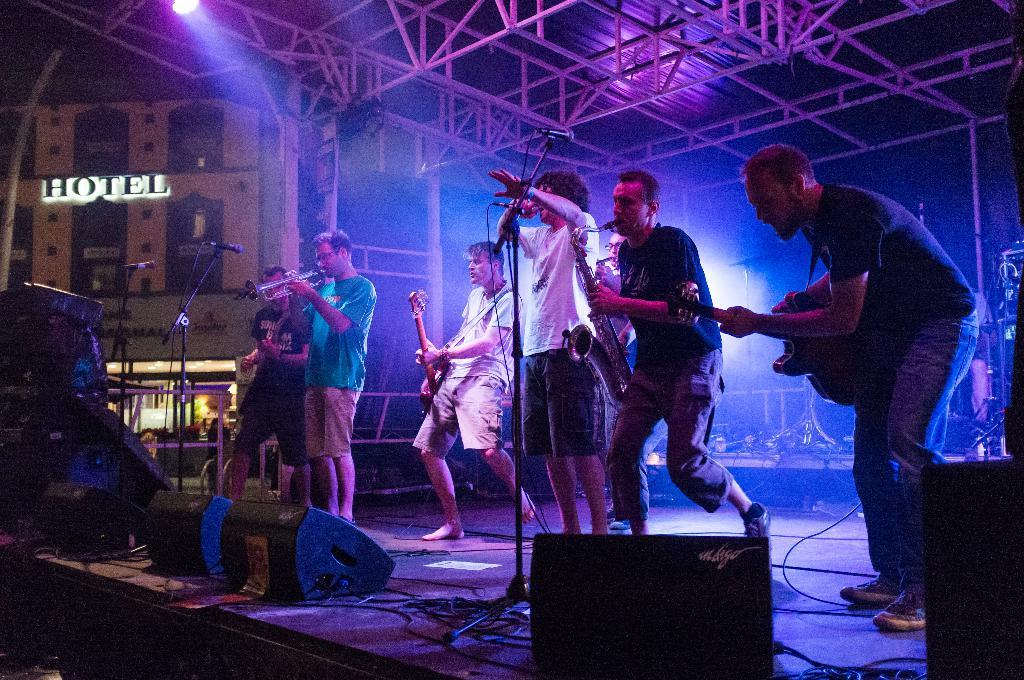What are the people in the image doing? The people in the image are playing musical instruments. Where are the people playing their instruments? The people are on a stage. What is present in front of the stage? There is a microphone in front of the stage. How many icicles can be seen hanging from the stage in the image? There are no icicles present in the image. What type of guide is assisting the musicians on stage? There is no guide present in the image; the people on stage are playing musical instruments without assistance. 